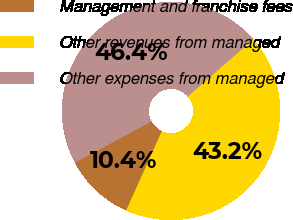<chart> <loc_0><loc_0><loc_500><loc_500><pie_chart><fcel>Management and franchise fees<fcel>Other revenues from managed<fcel>Other expenses from managed<nl><fcel>10.42%<fcel>43.15%<fcel>46.43%<nl></chart> 